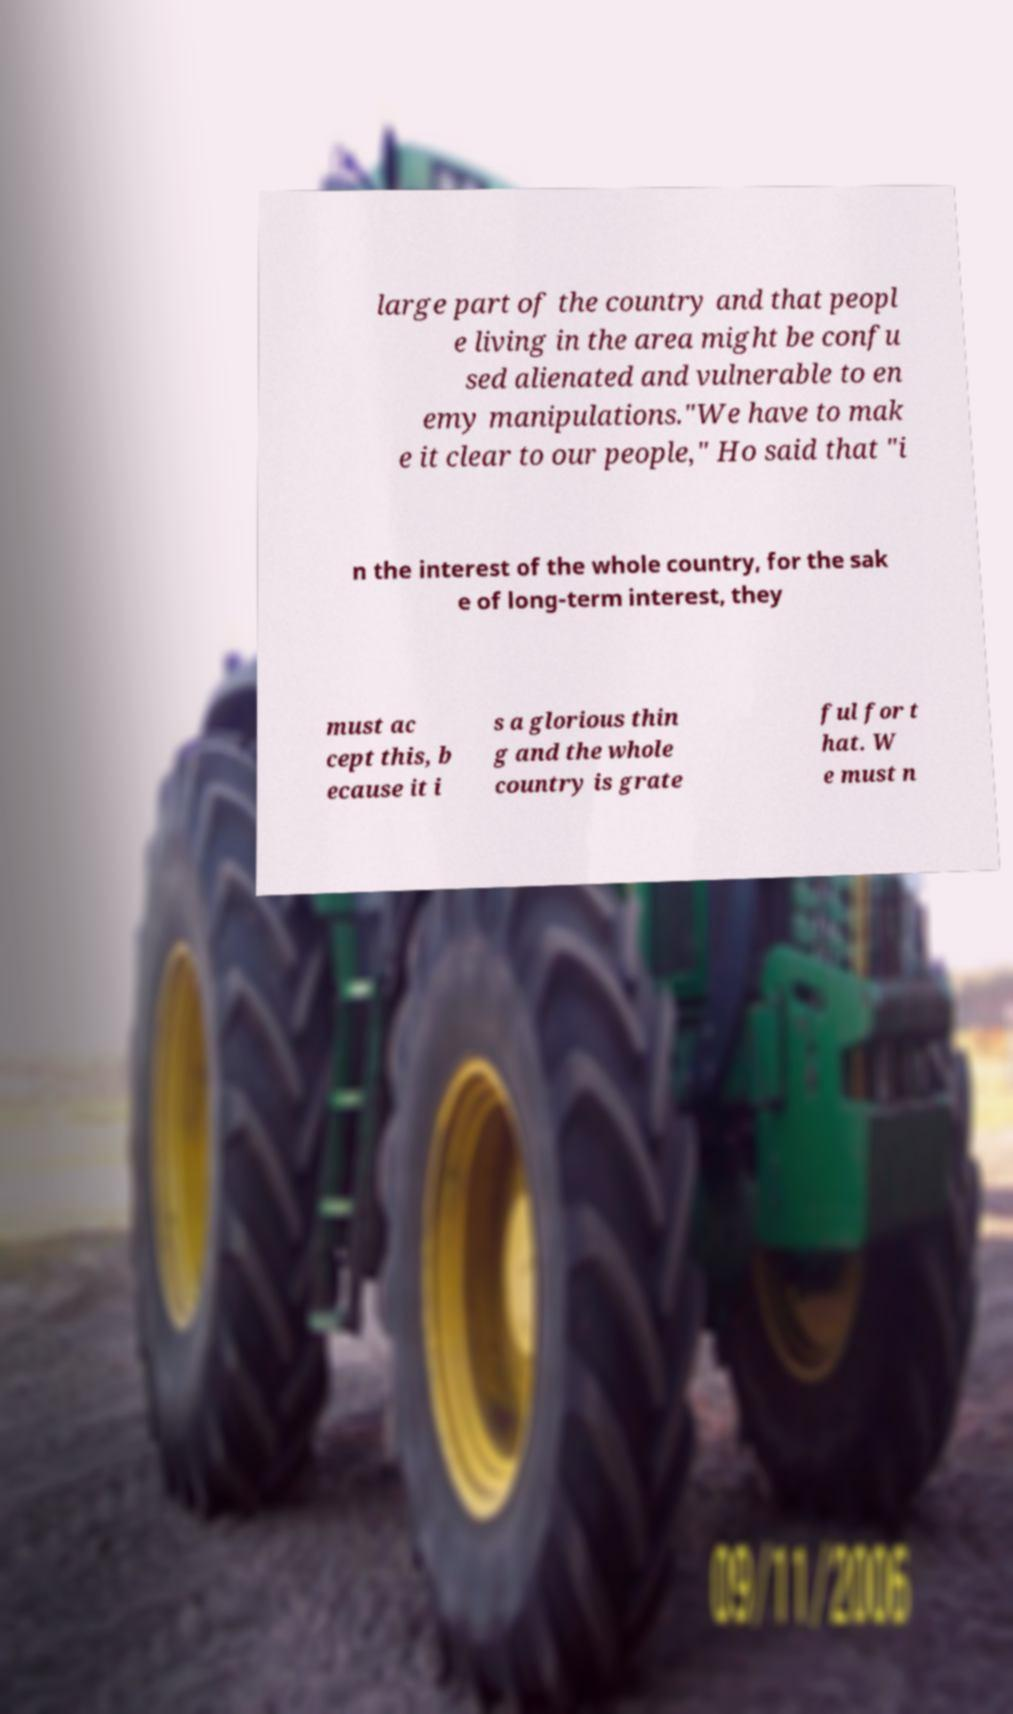Can you read and provide the text displayed in the image?This photo seems to have some interesting text. Can you extract and type it out for me? large part of the country and that peopl e living in the area might be confu sed alienated and vulnerable to en emy manipulations."We have to mak e it clear to our people," Ho said that "i n the interest of the whole country, for the sak e of long-term interest, they must ac cept this, b ecause it i s a glorious thin g and the whole country is grate ful for t hat. W e must n 